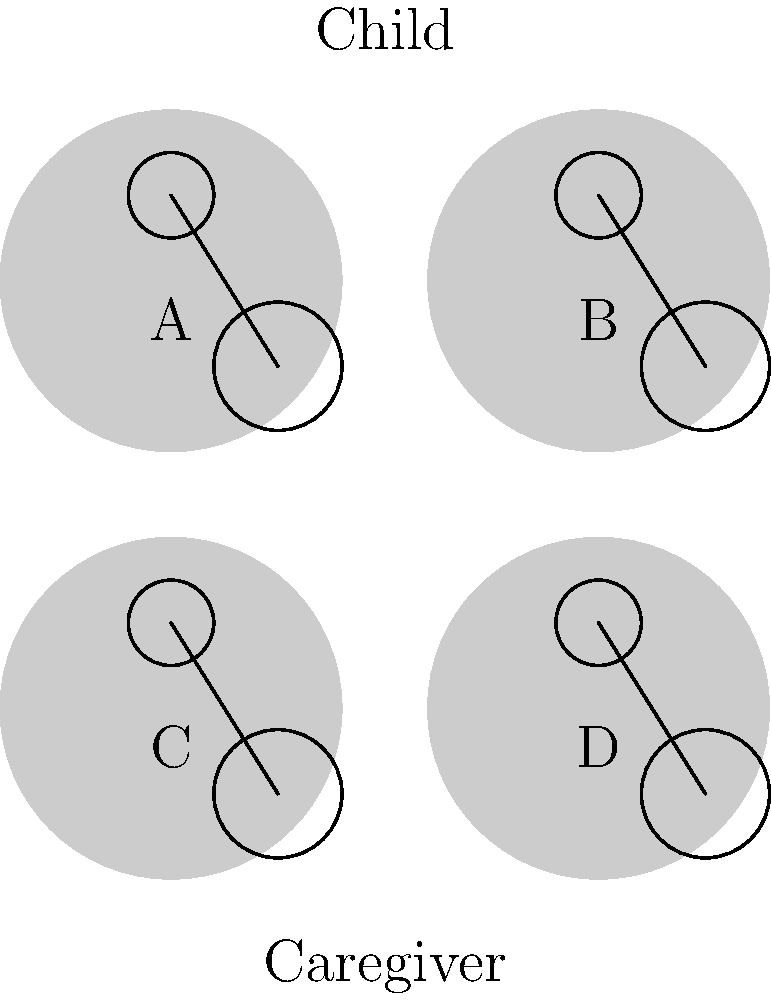As a child psychologist, analyze the four illustrated scenarios (A, B, C, and D) depicting child-caregiver interactions. Which scenario most likely represents a secure attachment style? To identify the scenario representing a secure attachment style, we need to consider the key characteristics of secure attachment and analyze each scenario:

1. Secure attachment is characterized by a child feeling comfortable exploring their environment while maintaining a sense of safety and connection with their caregiver.

2. In a secure attachment, the child uses the caregiver as a "secure base" from which to explore and as a "safe haven" to return to when feeling distressed.

3. Analyzing the scenarios:
   A: The child and caregiver are close together, suggesting a comfortable proximity.
   B: There is more distance between the child and caregiver, possibly indicating avoidance or independence.
   C: The child and caregiver are very close, potentially indicating anxiety or clinginess.
   D: The child and caregiver maintain a balanced distance, allowing for exploration while remaining connected.

4. Scenario D best represents secure attachment because:
   - The child is positioned slightly away from the caregiver, suggesting comfort in exploring.
   - The caregiver remains close enough to provide support if needed.
   - The distance between them is neither too close (anxious) nor too far (avoidant).

5. This balanced positioning in scenario D allows the child to feel safe exploring while knowing the caregiver is available, which is a hallmark of secure attachment.

Therefore, scenario D most likely represents a secure attachment style.
Answer: Scenario D 